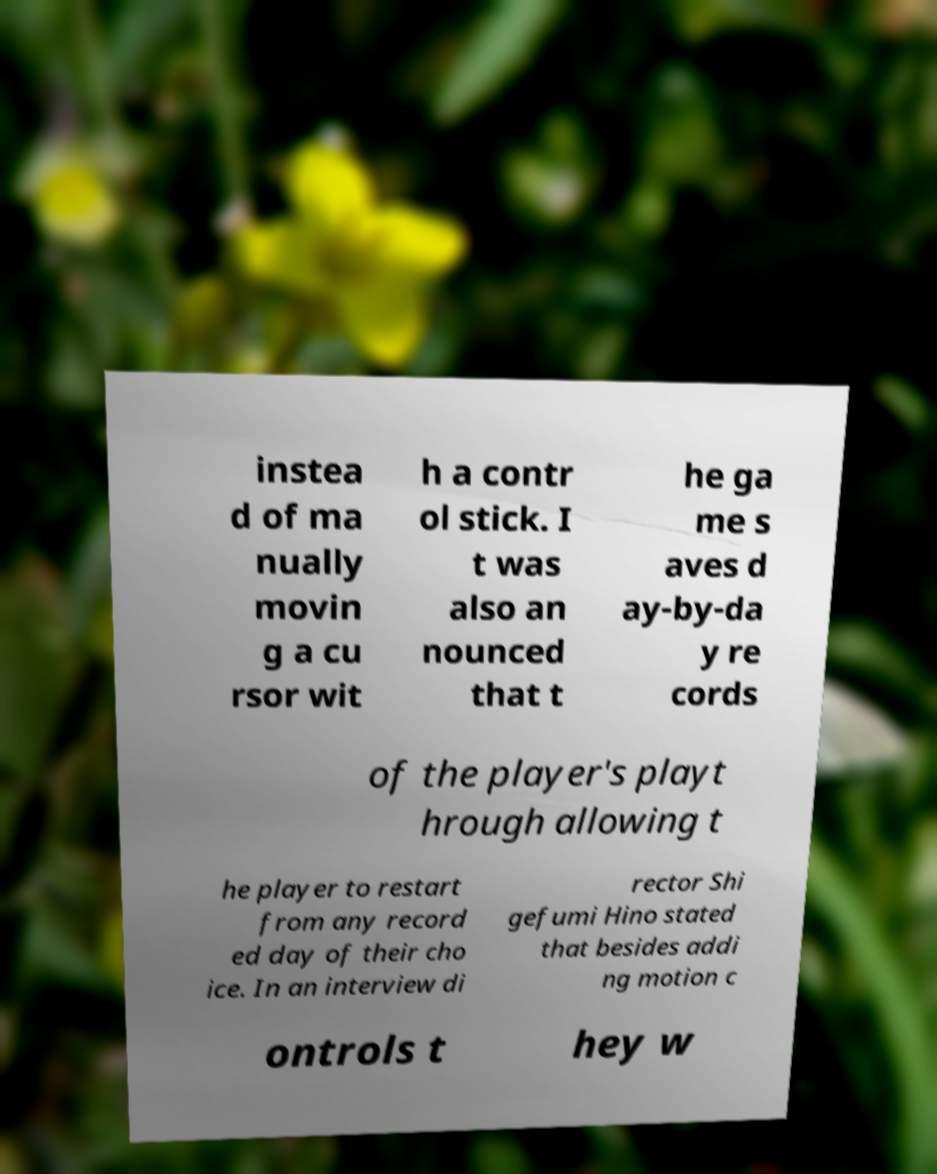Can you read and provide the text displayed in the image?This photo seems to have some interesting text. Can you extract and type it out for me? instea d of ma nually movin g a cu rsor wit h a contr ol stick. I t was also an nounced that t he ga me s aves d ay-by-da y re cords of the player's playt hrough allowing t he player to restart from any record ed day of their cho ice. In an interview di rector Shi gefumi Hino stated that besides addi ng motion c ontrols t hey w 